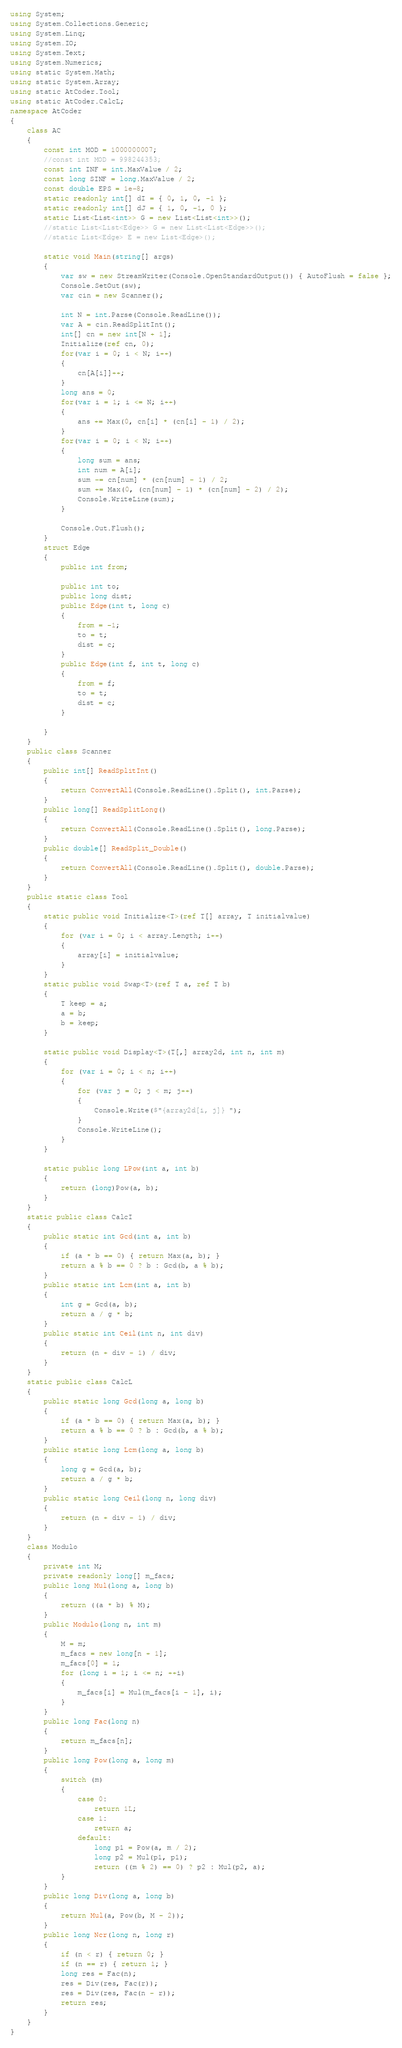Convert code to text. <code><loc_0><loc_0><loc_500><loc_500><_C#_>using System;
using System.Collections.Generic;
using System.Linq;
using System.IO;
using System.Text;
using System.Numerics;
using static System.Math;
using static System.Array;
using static AtCoder.Tool;
using static AtCoder.CalcL;
namespace AtCoder
{
    class AC
    {
        const int MOD = 1000000007;
        //const int MOD = 998244353;
        const int INF = int.MaxValue / 2;
        const long SINF = long.MaxValue / 2;
        const double EPS = 1e-8;
        static readonly int[] dI = { 0, 1, 0, -1 };
        static readonly int[] dJ = { 1, 0, -1, 0 };
        static List<List<int>> G = new List<List<int>>();
        //static List<List<Edge>> G = new List<List<Edge>>();
        //static List<Edge> E = new List<Edge>();
        
        static void Main(string[] args)
        {
            var sw = new StreamWriter(Console.OpenStandardOutput()) { AutoFlush = false };
            Console.SetOut(sw);
            var cin = new Scanner();

            int N = int.Parse(Console.ReadLine());
            var A = cin.ReadSplitInt();
            int[] cn = new int[N + 1];
            Initialize(ref cn, 0);
            for(var i = 0; i < N; i++)
            {
                cn[A[i]]++;
            }
            long ans = 0;
            for(var i = 1; i <= N; i++)
            {
                ans += Max(0, cn[i] * (cn[i] - 1) / 2);
            }
            for(var i = 0; i < N; i++)
            {
                long sum = ans;
                int num = A[i];
                sum -= cn[num] * (cn[num] - 1) / 2;
                sum += Max(0, (cn[num] - 1) * (cn[num] - 2) / 2);
                Console.WriteLine(sum);
            }

            Console.Out.Flush();
        }
        struct Edge
        {
            public int from;

            public int to;
            public long dist;
            public Edge(int t, long c)
            {
                from = -1;
                to = t;
                dist = c;
            }
            public Edge(int f, int t, long c)
            {
                from = f;
                to = t;
                dist = c;
            }

        }
    }
    public class Scanner
    {
        public int[] ReadSplitInt()
        {
            return ConvertAll(Console.ReadLine().Split(), int.Parse);
        }
        public long[] ReadSplitLong()
        {
            return ConvertAll(Console.ReadLine().Split(), long.Parse);
        }
        public double[] ReadSplit_Double()
        {
            return ConvertAll(Console.ReadLine().Split(), double.Parse);
        }
    }
    public static class Tool
    {
        static public void Initialize<T>(ref T[] array, T initialvalue)
        {
            for (var i = 0; i < array.Length; i++)
            {
                array[i] = initialvalue;
            }
        }
        static public void Swap<T>(ref T a, ref T b)
        {
            T keep = a;
            a = b;
            b = keep;
        }

        static public void Display<T>(T[,] array2d, int n, int m)
        {
            for (var i = 0; i < n; i++)
            {
                for (var j = 0; j < m; j++)
                {
                    Console.Write($"{array2d[i, j]} ");
                }
                Console.WriteLine();
            }
        }

        static public long LPow(int a, int b)
        {
            return (long)Pow(a, b);
        }
    }
    static public class CalcI
    {
        public static int Gcd(int a, int b)
        {
            if (a * b == 0) { return Max(a, b); }
            return a % b == 0 ? b : Gcd(b, a % b);
        }
        public static int Lcm(int a, int b)
        {
            int g = Gcd(a, b);
            return a / g * b;
        }
        public static int Ceil(int n, int div)
        {
            return (n + div - 1) / div;
        }
    }
    static public class CalcL
    {
        public static long Gcd(long a, long b)
        {
            if (a * b == 0) { return Max(a, b); }
            return a % b == 0 ? b : Gcd(b, a % b);
        }
        public static long Lcm(long a, long b)
        {
            long g = Gcd(a, b);
            return a / g * b;
        }
        public static long Ceil(long n, long div)
        {
            return (n + div - 1) / div;
        }
    }
    class Modulo
    {
        private int M;
        private readonly long[] m_facs;
        public long Mul(long a, long b)
        {
            return ((a * b) % M);
        }
        public Modulo(long n, int m)
        {
            M = m;
            m_facs = new long[n + 1];
            m_facs[0] = 1;
            for (long i = 1; i <= n; ++i)
            {
                m_facs[i] = Mul(m_facs[i - 1], i);
            }
        }
        public long Fac(long n)
        {
            return m_facs[n];
        }
        public long Pow(long a, long m)
        {
            switch (m)
            {
                case 0:
                    return 1L;
                case 1:
                    return a;
                default:
                    long p1 = Pow(a, m / 2);
                    long p2 = Mul(p1, p1);
                    return ((m % 2) == 0) ? p2 : Mul(p2, a);
            }
        }
        public long Div(long a, long b)
        {
            return Mul(a, Pow(b, M - 2));
        }
        public long Ncr(long n, long r)
        {
            if (n < r) { return 0; }
            if (n == r) { return 1; }
            long res = Fac(n);
            res = Div(res, Fac(r));
            res = Div(res, Fac(n - r));
            return res;
        }
    }
}
</code> 